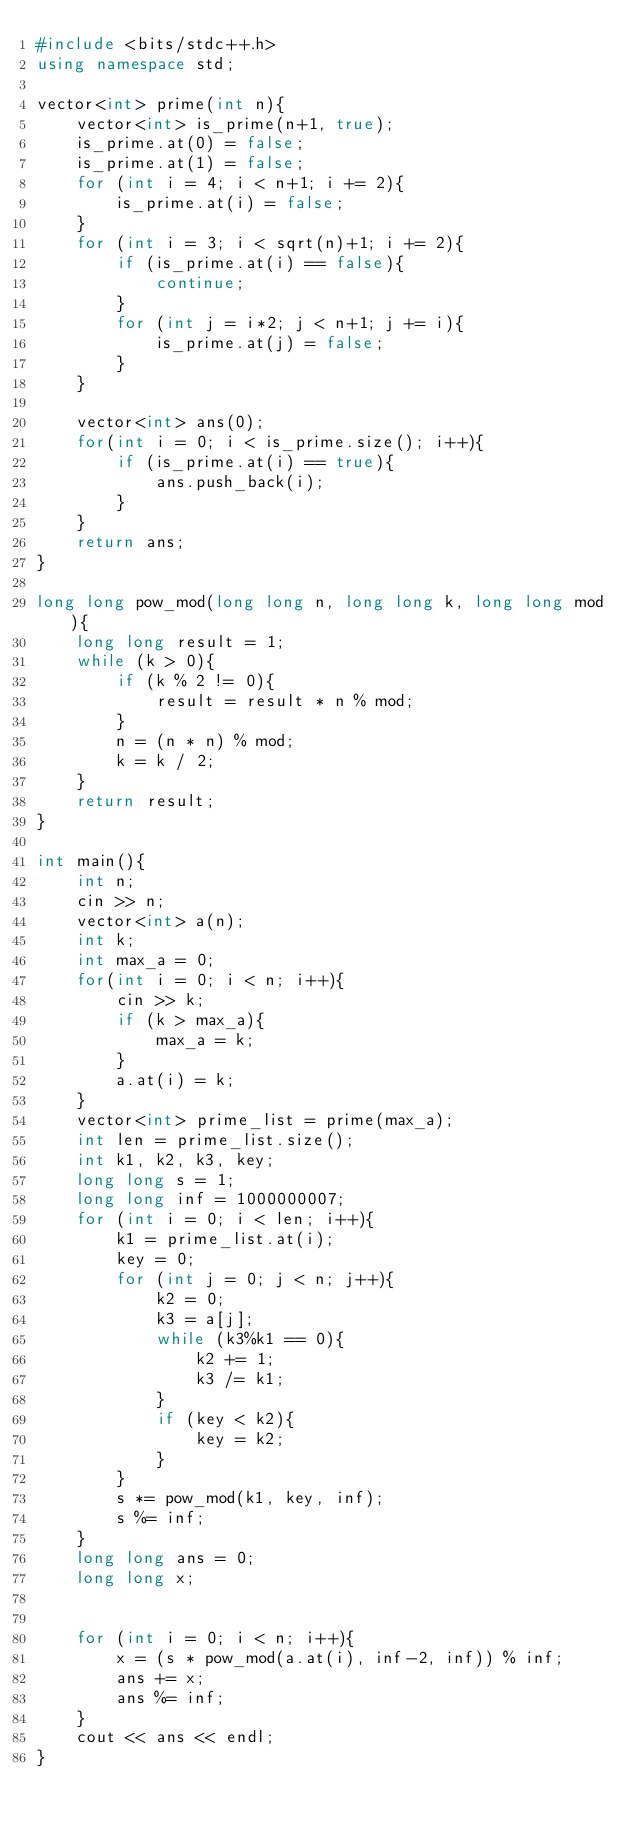<code> <loc_0><loc_0><loc_500><loc_500><_C++_>#include <bits/stdc++.h>
using namespace std;

vector<int> prime(int n){
    vector<int> is_prime(n+1, true);
    is_prime.at(0) = false;
    is_prime.at(1) = false;
    for (int i = 4; i < n+1; i += 2){
        is_prime.at(i) = false;
    }
    for (int i = 3; i < sqrt(n)+1; i += 2){
        if (is_prime.at(i) == false){
            continue;
        }
        for (int j = i*2; j < n+1; j += i){
            is_prime.at(j) = false;
        }
    }
    
    vector<int> ans(0);
    for(int i = 0; i < is_prime.size(); i++){
        if (is_prime.at(i) == true){
            ans.push_back(i);
        }
    }
    return ans;
}

long long pow_mod(long long n, long long k, long long mod){
    long long result = 1;
    while (k > 0){
        if (k % 2 != 0){
            result = result * n % mod;
        }
        n = (n * n) % mod;
        k = k / 2;
    }
    return result;
}

int main(){
    int n;
    cin >> n;
    vector<int> a(n);
    int k;
    int max_a = 0;
    for(int i = 0; i < n; i++){
        cin >> k;
        if (k > max_a){
            max_a = k;
        }
        a.at(i) = k;
    }
    vector<int> prime_list = prime(max_a);
    int len = prime_list.size();
    int k1, k2, k3, key;
    long long s = 1;
    long long inf = 1000000007;
    for (int i = 0; i < len; i++){
        k1 = prime_list.at(i);
        key = 0;
        for (int j = 0; j < n; j++){
            k2 = 0;
            k3 = a[j];
            while (k3%k1 == 0){
                k2 += 1;
                k3 /= k1;
            }
            if (key < k2){
                key = k2;
            }
        }
        s *= pow_mod(k1, key, inf);
        s %= inf;
    }
    long long ans = 0;
    long long x;
    

    for (int i = 0; i < n; i++){
        x = (s * pow_mod(a.at(i), inf-2, inf)) % inf;
        ans += x;
        ans %= inf;
    }
    cout << ans << endl;
}</code> 